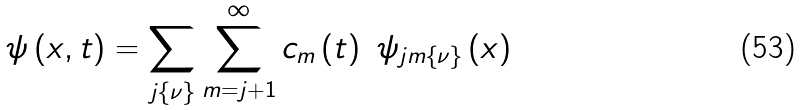Convert formula to latex. <formula><loc_0><loc_0><loc_500><loc_500>\psi \left ( x , t \right ) = \sum _ { j \left \{ \nu \right \} } \sum _ { m = j + 1 } ^ { \infty } c _ { m } \left ( t \right ) \ \psi _ { j m \left \{ \nu \right \} } \left ( x \right )</formula> 